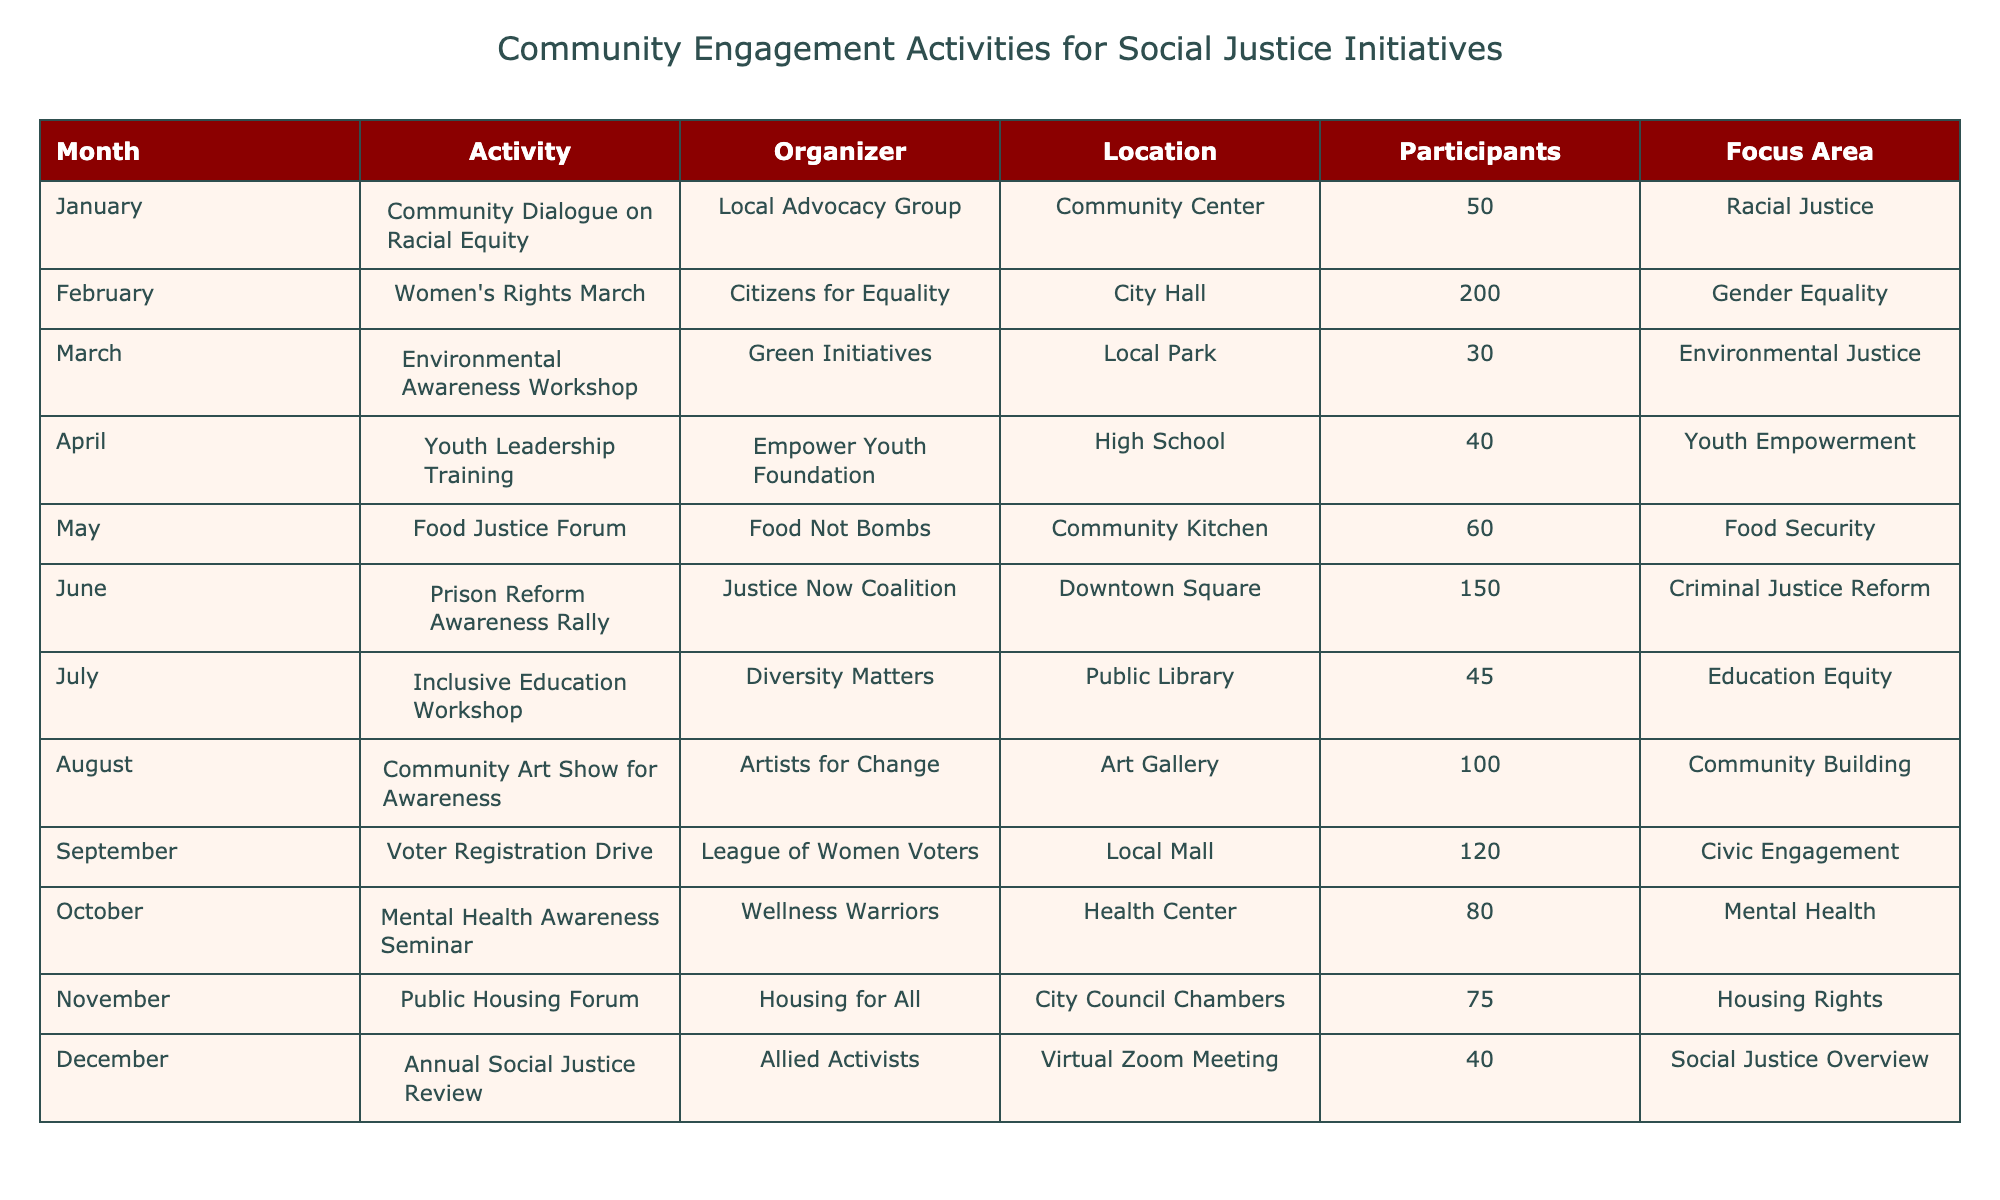What activity took place in June? From the table, I can look directly to the entry for June, which shows the activity listed is "Prison Reform Awareness Rally."
Answer: Prison Reform Awareness Rally How many participants attended the Women’s Rights March? By checking the row for February, I see that the Women’s Rights March had 200 participants.
Answer: 200 What is the total number of participants across all activities? I will add the participants from each row: 50 + 200 + 30 + 40 + 60 + 150 + 45 + 100 + 120 + 80 + 75 + 40 = 1,010. Thus, the total is 1,010.
Answer: 1010 Was there an activity focused on Mental Health? Checking the Focus Area column, I see that the activity titled "Mental Health Awareness Seminar" in October indeed focuses on Mental Health. Therefore, the answer is yes.
Answer: Yes Which organizer is associated with the Food Justice Forum? According to the May entry, the Food Justice Forum is organized by "Food Not Bombs."
Answer: Food Not Bombs What is the average number of participants for activities focused on Racial Justice and Gender Equality? The Racial Justice activity in January had 50 participants, and the Gender Equality activity in February had 200. Summing these gives 50 + 200 = 250. To find the average, I divide by the number of activities, which is 2: 250 / 2 = 125.
Answer: 125 Identify the focus area of the Youth Leadership Training. From April’s entry in the table, it indicates that the focus area for the Youth Leadership Training is "Youth Empowerment."
Answer: Youth Empowerment How many activities were held at a library location? Referring to the locations listed, I find that only the "Inclusive Education Workshop" was organized at a Public Library, making it one activity.
Answer: 1 Which month had an equal number of participants for activities? The participants in the Annual Social Justice Review in December had 40, which is also the same as the Youth Leadership Training in April, who had 40 participants. Hence, these months (April and December) had an equal number of participants.
Answer: April and December 